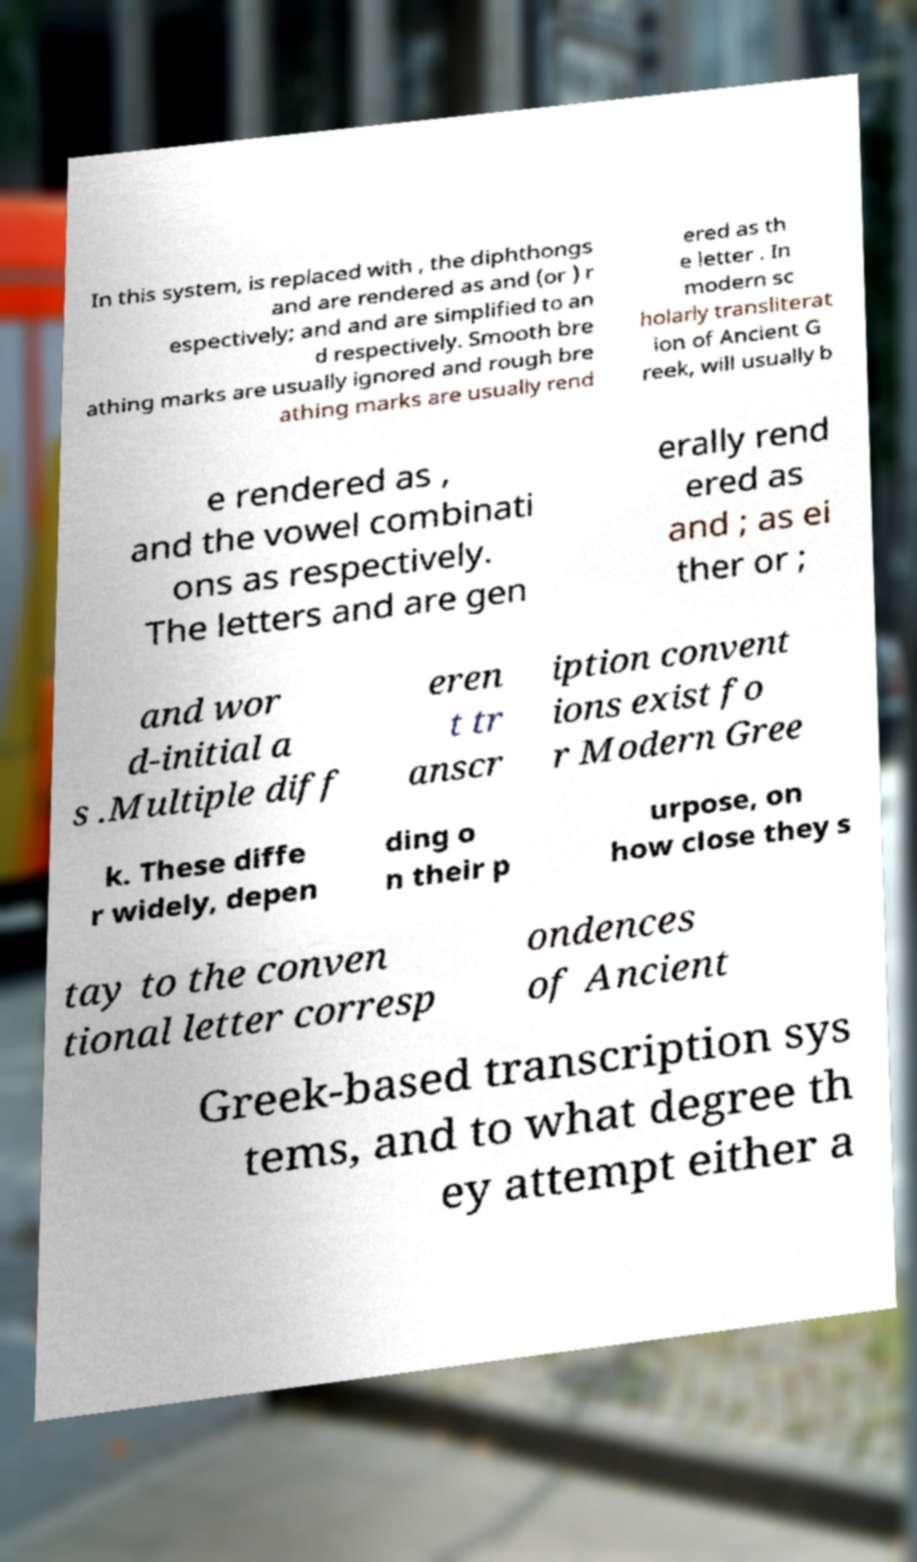What messages or text are displayed in this image? I need them in a readable, typed format. In this system, is replaced with , the diphthongs and are rendered as and (or ) r espectively; and and are simplified to an d respectively. Smooth bre athing marks are usually ignored and rough bre athing marks are usually rend ered as th e letter . In modern sc holarly transliterat ion of Ancient G reek, will usually b e rendered as , and the vowel combinati ons as respectively. The letters and are gen erally rend ered as and ; as ei ther or ; and wor d-initial a s .Multiple diff eren t tr anscr iption convent ions exist fo r Modern Gree k. These diffe r widely, depen ding o n their p urpose, on how close they s tay to the conven tional letter corresp ondences of Ancient Greek-based transcription sys tems, and to what degree th ey attempt either a 